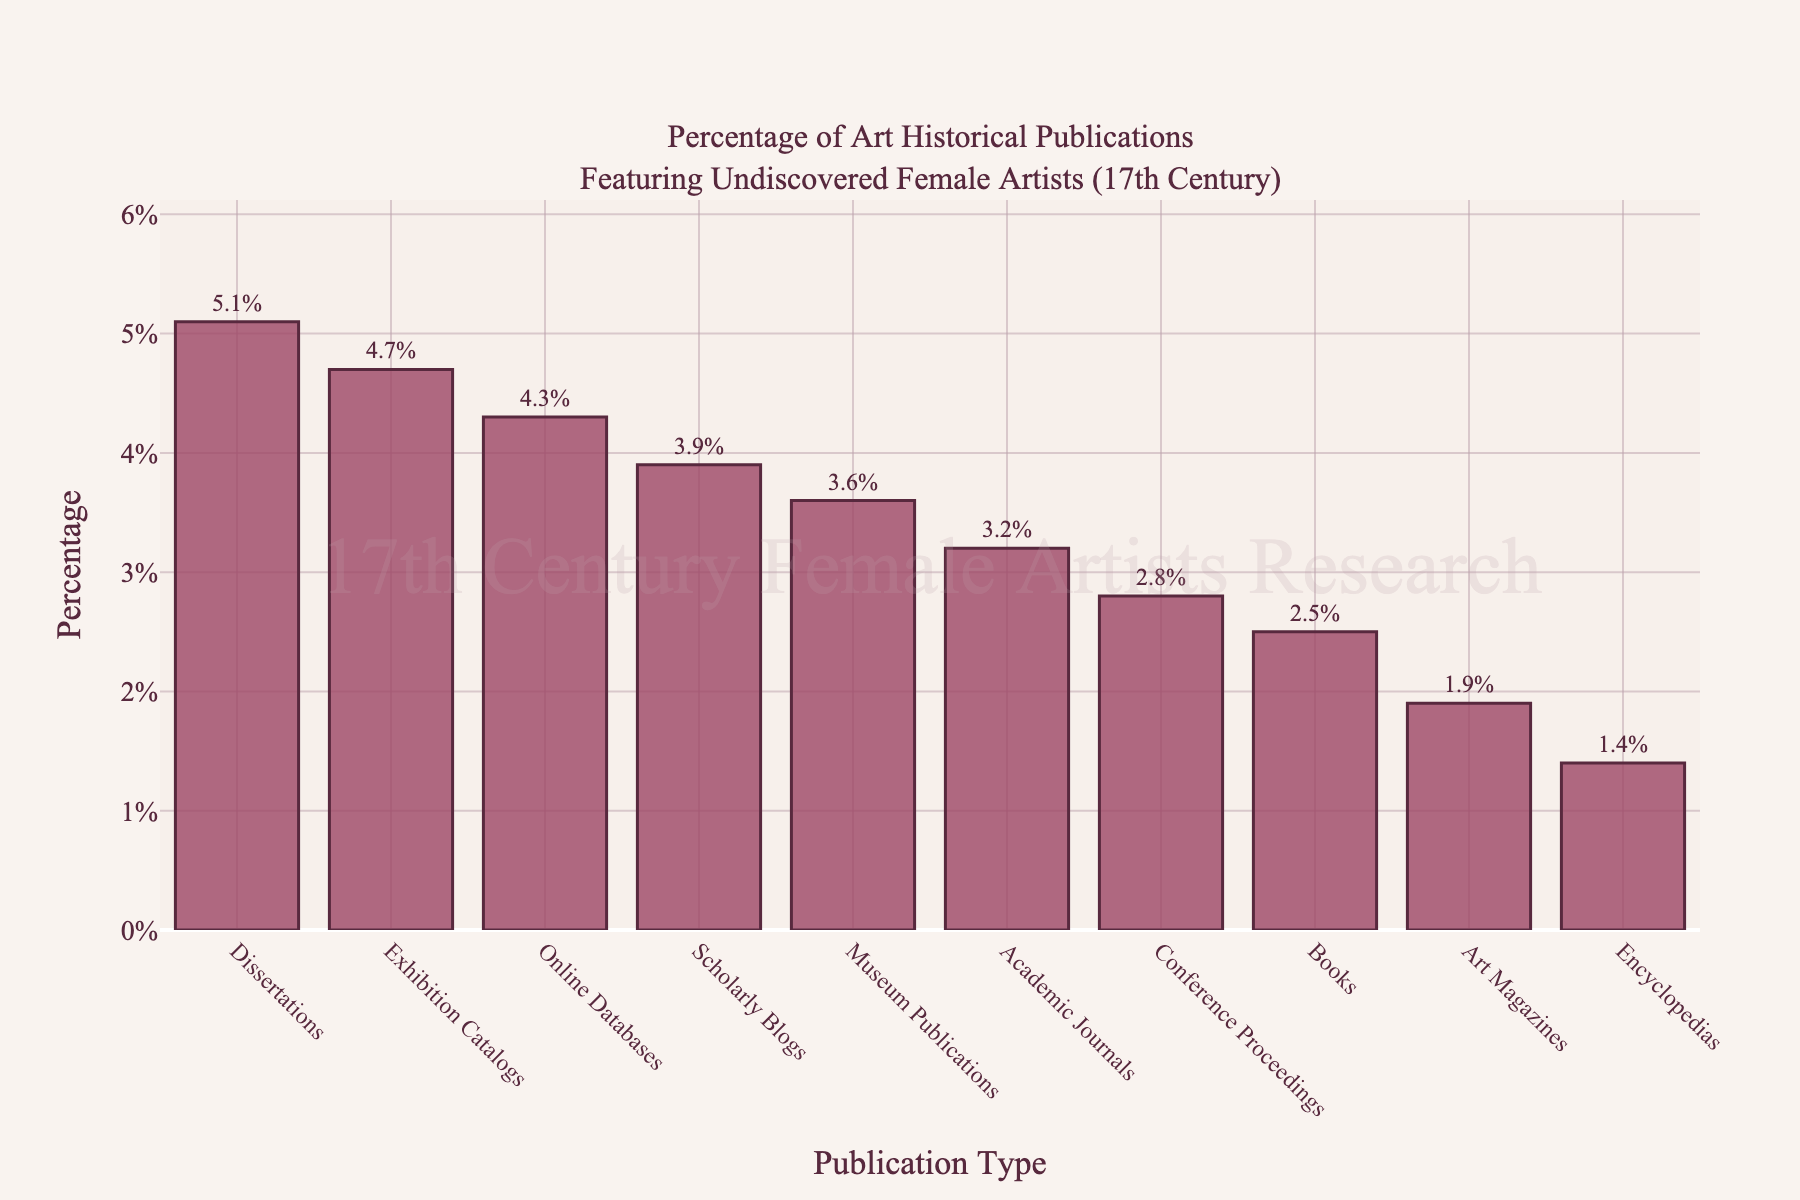What's the average percentage of publications featuring undiscovered female artists from the 17th century? To find the average, sum up all the percentages and divide by the number of publication types. The sum of the percentages is (3.2 + 2.5 + 4.7 + 2.8 + 5.1 + 1.9 + 3.6 + 4.3 + 1.4 + 3.9) = 33.4. There are 10 publication types, so the average is 33.4 / 10 = 3.34.
Answer: 3.34% Which publication type features undiscovered female artists the most? By examining the heights of the bars in the chart, we see that the publication type with the highest percentage is "Dissertations" with 5.1%.
Answer: Dissertations Which publication type features undiscovered female artists the least? By examining the heights of the bars in the chart, we see that the publication type with the lowest percentage is "Encyclopedias" with 1.4%.
Answer: Encyclopedias What is the difference in percentage between the publication type with the highest and the lowest representation? The highest percentage is for "Dissertations" at 5.1% and the lowest is for "Encyclopedias" at 1.4%. The difference is 5.1 - 1.4 = 3.7.
Answer: 3.7% How many publication types have a percentage higher than 3%? By inspecting the chart, the publication types with more than 3% are "Academic Journals" (3.2%), "Exhibition Catalogs" (4.7%), "Dissertations" (5.1%), "Museum Publications" (3.6%), "Online Databases" (4.3%), and "Scholarly Blogs" (3.9%). There are 6 publication types, so the answer is six.
Answer: 6 Is there any publication type with exactly a 2.8% representation? By inspecting the chart, we see that "Conference Proceedings" has exactly a 2.8% representation.
Answer: Conference Proceedings What is the combined percentage of "Exhibition Catalogs" and "Online Databases"? "Exhibition Catalogs" has 4.7% and "Online Databases" has 4.3%. Their combined percentage is 4.7 + 4.3 = 9.0.
Answer: 9.0% Which publication types have a higher representation than "Academic Journals"? The publication types with higher percentages than "Academic Journals" (3.2%) are "Exhibition Catalogs" (4.7%), "Dissertations" (5.1%), "Online Databases" (4.3%), and "Scholarly Blogs" (3.9%).
Answer: Exhibition Catalogs, Dissertations, Online Databases, Scholarly Blogs Does the color coding influence the visual saliency of the highest and lowest percentages? The bar chart uses a consistent color scheme with a deep red for the bars and a darker outline. This consistency means that individual bar heights are what determine visual saliency, emphasizing "Dissertations" (highest) and "Encyclopedias" (lowest) naturally without additional color cues.
Answer: No 